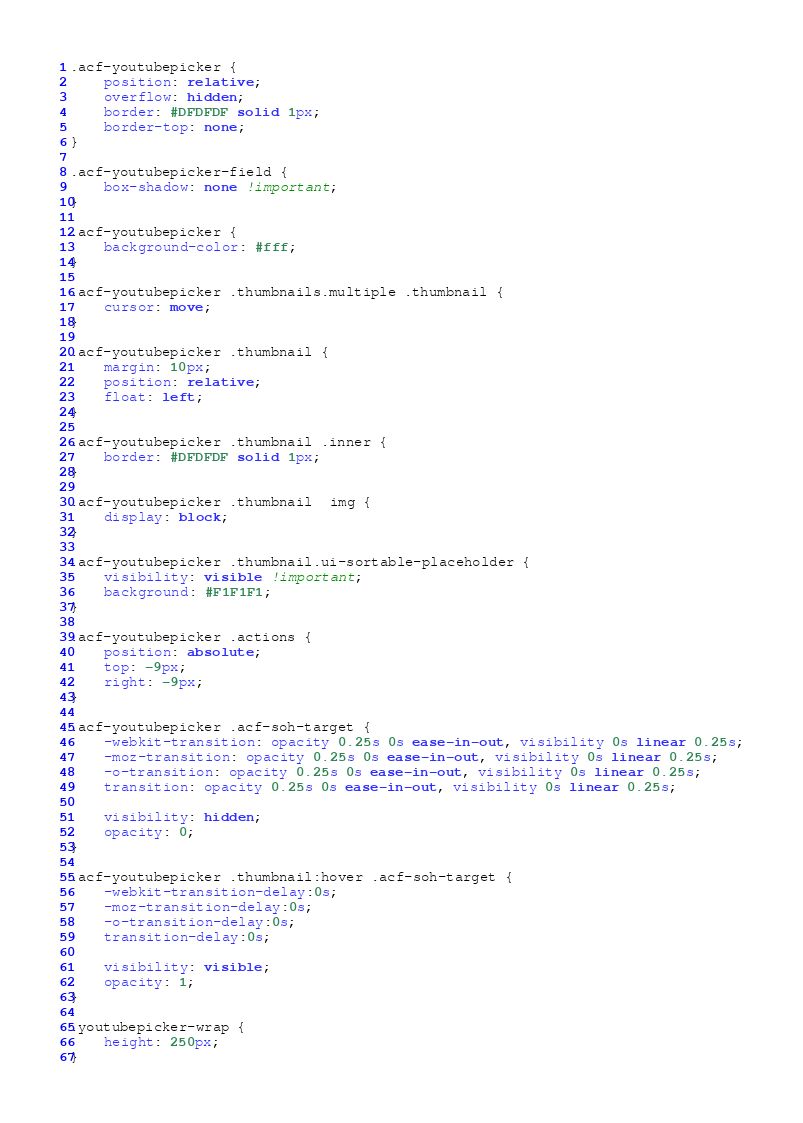Convert code to text. <code><loc_0><loc_0><loc_500><loc_500><_CSS_>.acf-youtubepicker {
	position: relative;
	overflow: hidden;
	border: #DFDFDF solid 1px;
	border-top: none;
}

.acf-youtubepicker-field {
	box-shadow: none !important;
}

.acf-youtubepicker {
	background-color: #fff;
}

.acf-youtubepicker .thumbnails.multiple .thumbnail {
	cursor: move;
}

.acf-youtubepicker .thumbnail {
	margin: 10px;
	position: relative;
	float: left;
}

.acf-youtubepicker .thumbnail .inner {
	border: #DFDFDF solid 1px;
}

.acf-youtubepicker .thumbnail  img {
	display: block;
}

.acf-youtubepicker .thumbnail.ui-sortable-placeholder {
	visibility: visible !important;
	background: #F1F1F1;
}

.acf-youtubepicker .actions {
	position: absolute;
	top: -9px;
	right: -9px;	
}

.acf-youtubepicker .acf-soh-target {
	-webkit-transition: opacity 0.25s 0s ease-in-out, visibility 0s linear 0.25s;
	-moz-transition: opacity 0.25s 0s ease-in-out, visibility 0s linear 0.25s;
	-o-transition: opacity 0.25s 0s ease-in-out, visibility 0s linear 0.25s; 	
	transition: opacity 0.25s 0s ease-in-out, visibility 0s linear 0.25s; 
	
	visibility: hidden;
	opacity: 0;
}

.acf-youtubepicker .thumbnail:hover .acf-soh-target {
	-webkit-transition-delay:0s;
	-moz-transition-delay:0s;
	-o-transition-delay:0s;
	transition-delay:0s;

	visibility: visible;
	opacity: 1;
}

.youtubepicker-wrap {
	height: 250px;
}
</code> 